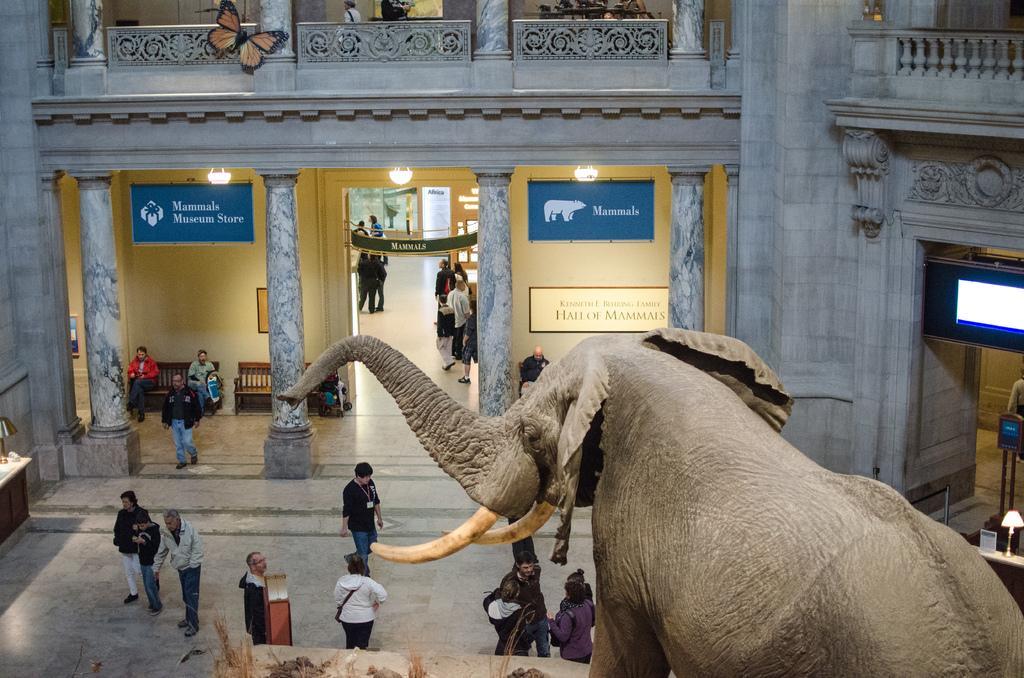How would you summarize this image in a sentence or two? There is a monument of an elephant at the bottom of this image. There are some persons standing in the background. There is a wall of a building as we can see at the top of this image. 